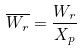<formula> <loc_0><loc_0><loc_500><loc_500>\overline { W _ { r } } = \frac { W _ { r } } { X _ { p } }</formula> 